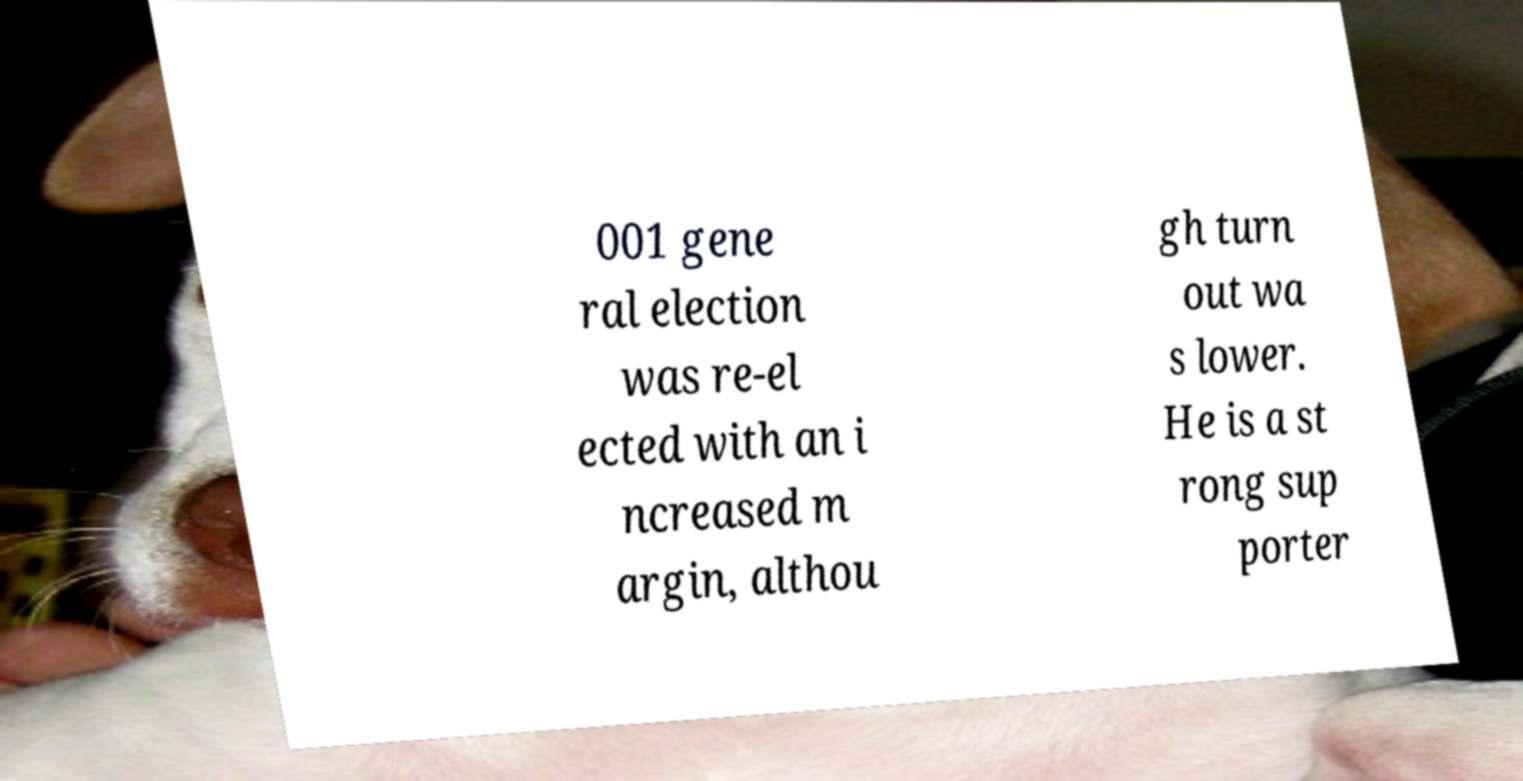I need the written content from this picture converted into text. Can you do that? 001 gene ral election was re-el ected with an i ncreased m argin, althou gh turn out wa s lower. He is a st rong sup porter 